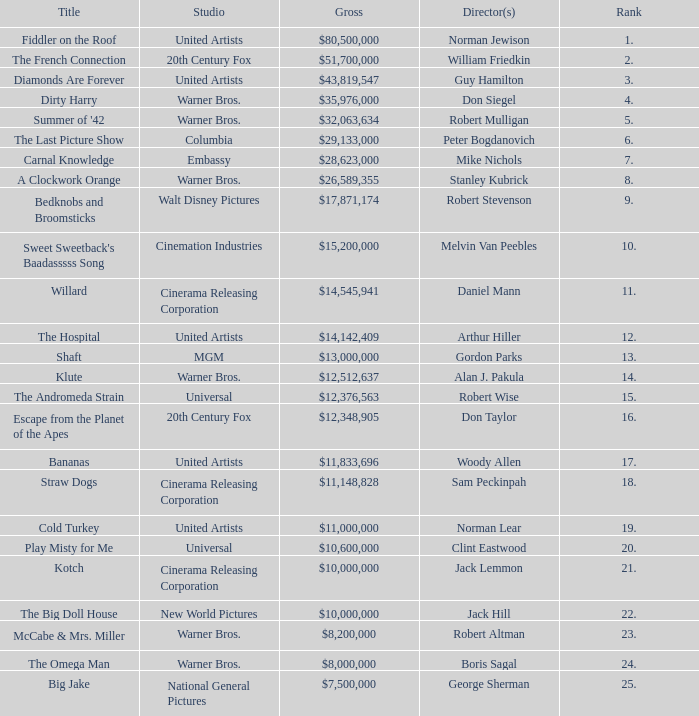Help me parse the entirety of this table. {'header': ['Title', 'Studio', 'Gross', 'Director(s)', 'Rank'], 'rows': [['Fiddler on the Roof', 'United Artists', '$80,500,000', 'Norman Jewison', '1.'], ['The French Connection', '20th Century Fox', '$51,700,000', 'William Friedkin', '2.'], ['Diamonds Are Forever', 'United Artists', '$43,819,547', 'Guy Hamilton', '3.'], ['Dirty Harry', 'Warner Bros.', '$35,976,000', 'Don Siegel', '4.'], ["Summer of '42", 'Warner Bros.', '$32,063,634', 'Robert Mulligan', '5.'], ['The Last Picture Show', 'Columbia', '$29,133,000', 'Peter Bogdanovich', '6.'], ['Carnal Knowledge', 'Embassy', '$28,623,000', 'Mike Nichols', '7.'], ['A Clockwork Orange', 'Warner Bros.', '$26,589,355', 'Stanley Kubrick', '8.'], ['Bedknobs and Broomsticks', 'Walt Disney Pictures', '$17,871,174', 'Robert Stevenson', '9.'], ["Sweet Sweetback's Baadasssss Song", 'Cinemation Industries', '$15,200,000', 'Melvin Van Peebles', '10.'], ['Willard', 'Cinerama Releasing Corporation', '$14,545,941', 'Daniel Mann', '11.'], ['The Hospital', 'United Artists', '$14,142,409', 'Arthur Hiller', '12.'], ['Shaft', 'MGM', '$13,000,000', 'Gordon Parks', '13.'], ['Klute', 'Warner Bros.', '$12,512,637', 'Alan J. Pakula', '14.'], ['The Andromeda Strain', 'Universal', '$12,376,563', 'Robert Wise', '15.'], ['Escape from the Planet of the Apes', '20th Century Fox', '$12,348,905', 'Don Taylor', '16.'], ['Bananas', 'United Artists', '$11,833,696', 'Woody Allen', '17.'], ['Straw Dogs', 'Cinerama Releasing Corporation', '$11,148,828', 'Sam Peckinpah', '18.'], ['Cold Turkey', 'United Artists', '$11,000,000', 'Norman Lear', '19.'], ['Play Misty for Me', 'Universal', '$10,600,000', 'Clint Eastwood', '20.'], ['Kotch', 'Cinerama Releasing Corporation', '$10,000,000', 'Jack Lemmon', '21.'], ['The Big Doll House', 'New World Pictures', '$10,000,000', 'Jack Hill', '22.'], ['McCabe & Mrs. Miller', 'Warner Bros.', '$8,200,000', 'Robert Altman', '23.'], ['The Omega Man', 'Warner Bros.', '$8,000,000', 'Boris Sagal', '24.'], ['Big Jake', 'National General Pictures', '$7,500,000', 'George Sherman', '25.']]} What is the rank of The Big Doll House? 22.0. 